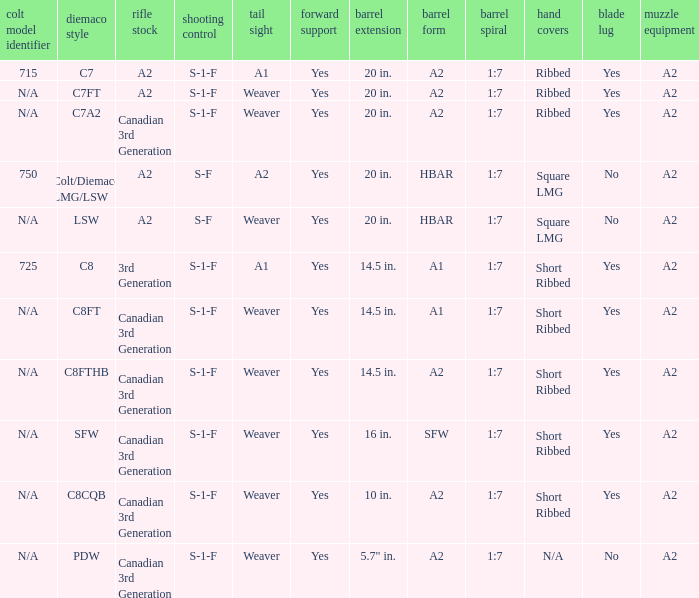Which Barrel twist has a Stock of canadian 3rd generation and a Hand guards of short ribbed? 1:7, 1:7, 1:7, 1:7. 